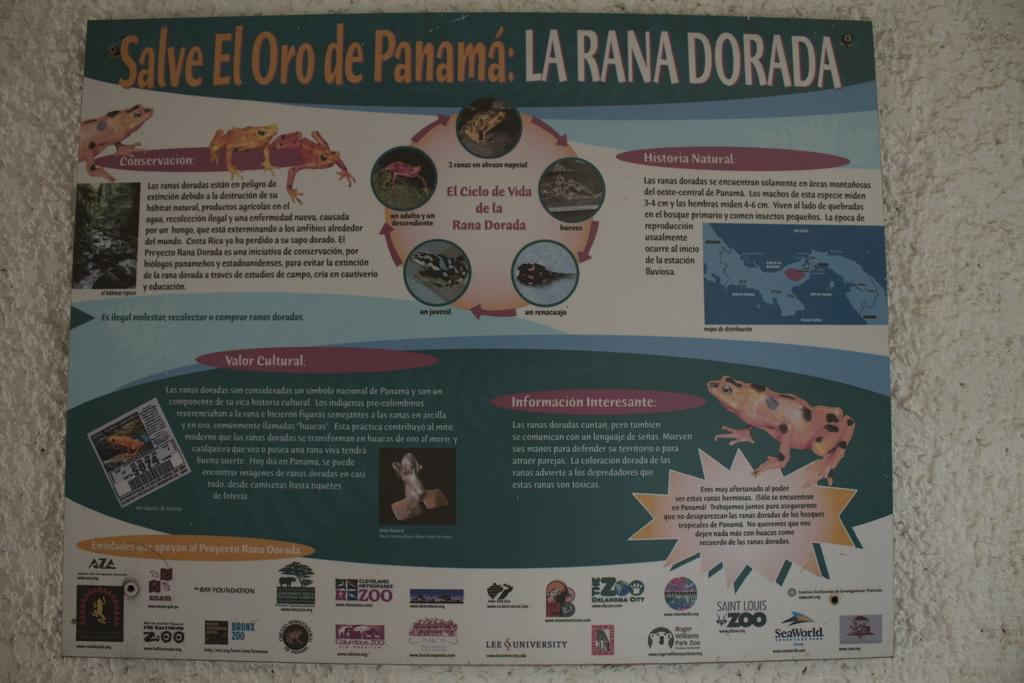<image>
Present a compact description of the photo's key features. An infographic about Salve El Oro de Panama. 